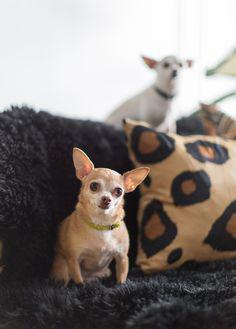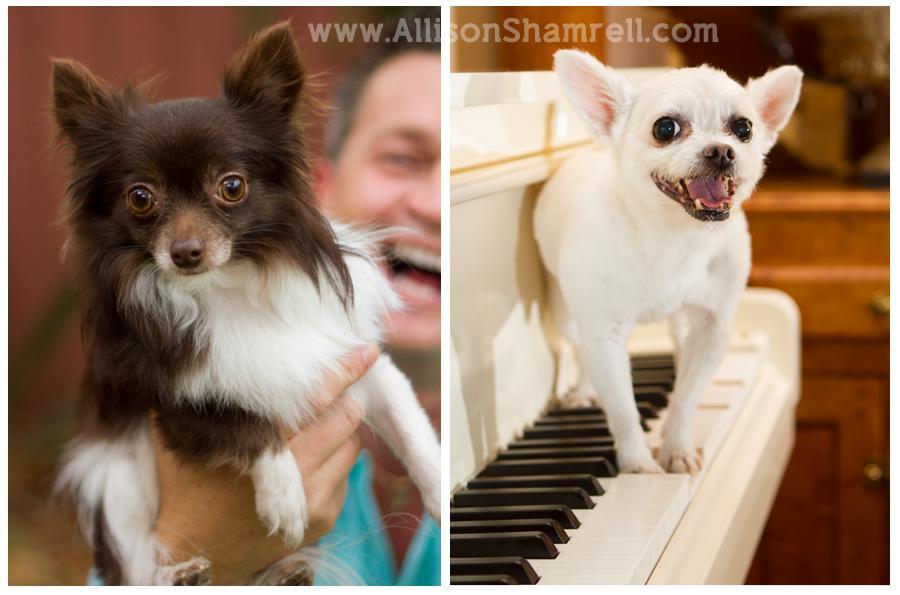The first image is the image on the left, the second image is the image on the right. Examine the images to the left and right. Is the description "At least one image shows two similarly colored chihuahuas." accurate? Answer yes or no. No. The first image is the image on the left, the second image is the image on the right. Analyze the images presented: Is the assertion "Atleast one image contains both a brown and white chihuahua." valid? Answer yes or no. Yes. 